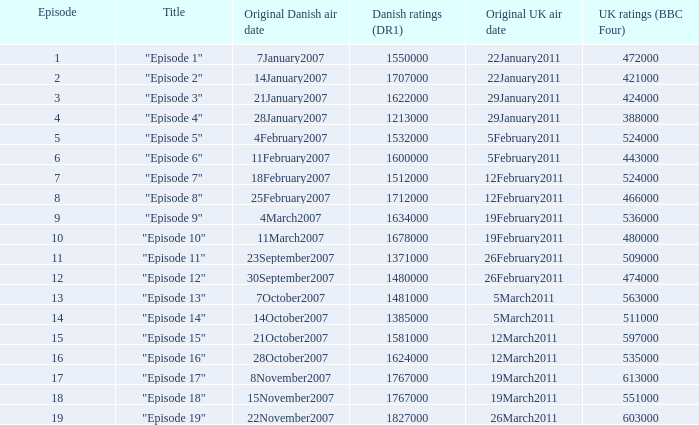What were the uk viewer statistics (bbc four) for "episode 17"? 613000.0. 